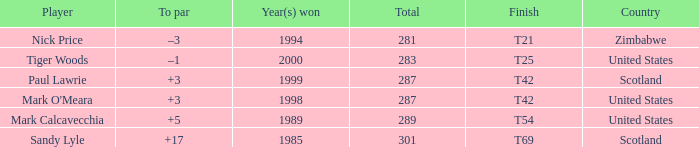Could you parse the entire table as a dict? {'header': ['Player', 'To par', 'Year(s) won', 'Total', 'Finish', 'Country'], 'rows': [['Nick Price', '–3', '1994', '281', 'T21', 'Zimbabwe'], ['Tiger Woods', '–1', '2000', '283', 'T25', 'United States'], ['Paul Lawrie', '+3', '1999', '287', 'T42', 'Scotland'], ["Mark O'Meara", '+3', '1998', '287', 'T42', 'United States'], ['Mark Calcavecchia', '+5', '1989', '289', 'T54', 'United States'], ['Sandy Lyle', '+17', '1985', '301', 'T69', 'Scotland']]} What is the to par when the year(s) won is larger than 1999? –1. 